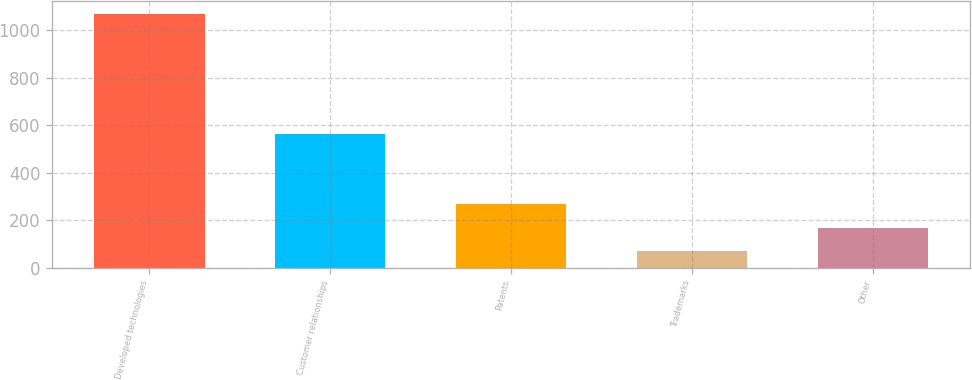Convert chart to OTSL. <chart><loc_0><loc_0><loc_500><loc_500><bar_chart><fcel>Developed technologies<fcel>Customer relationships<fcel>Patents<fcel>Trademarks<fcel>Other<nl><fcel>1069<fcel>563<fcel>269<fcel>69<fcel>169<nl></chart> 